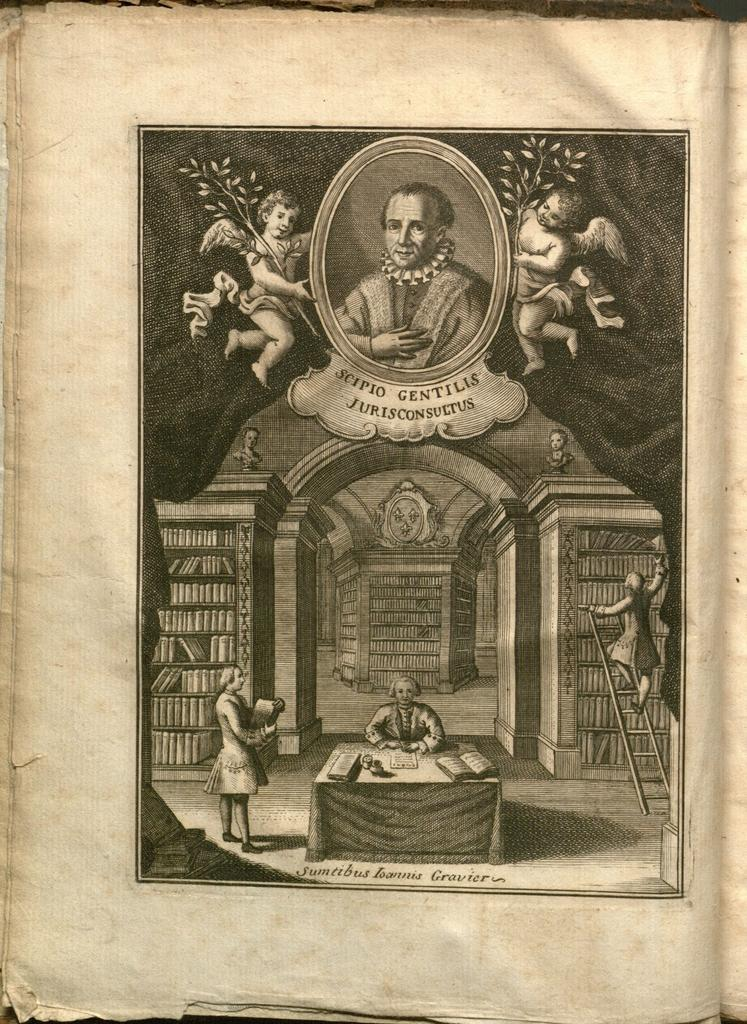What is the main object in the image? There is a paper in the image. What can be seen on the paper? The paper contains images of people. What piece of furniture is in the image? There is a table in the image. What else is on the table besides the paper? There are books on the table. What is the person doing in the image? A person is on the ladder. What type of trousers is the person wearing while on the ladder in the image? There is no information about the person's clothing in the image, so we cannot determine if they are wearing trousers or any other type of clothing. 